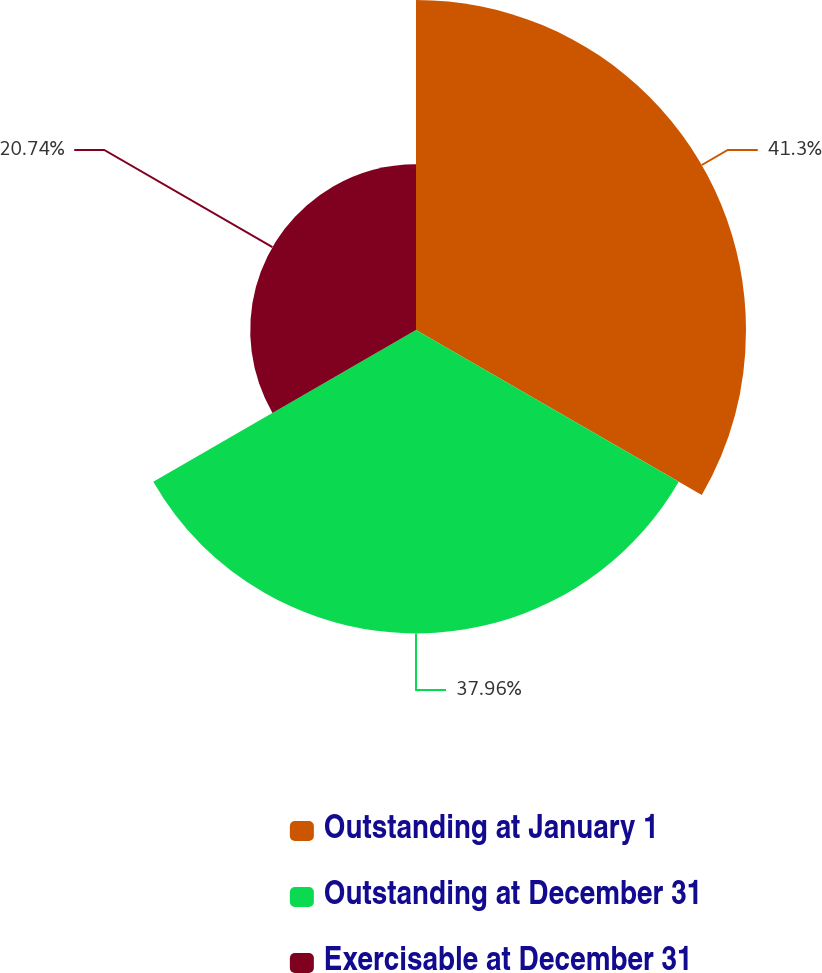<chart> <loc_0><loc_0><loc_500><loc_500><pie_chart><fcel>Outstanding at January 1<fcel>Outstanding at December 31<fcel>Exercisable at December 31<nl><fcel>41.29%<fcel>37.96%<fcel>20.74%<nl></chart> 